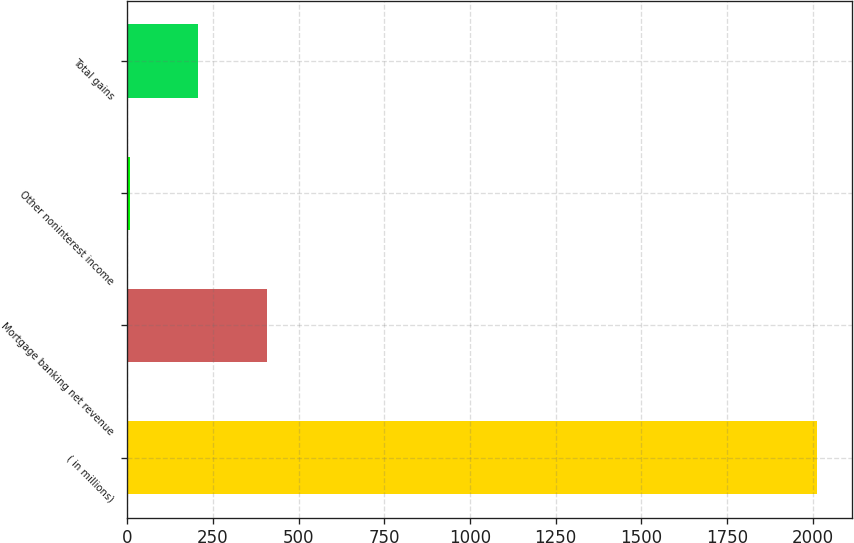Convert chart. <chart><loc_0><loc_0><loc_500><loc_500><bar_chart><fcel>( in millions)<fcel>Mortgage banking net revenue<fcel>Other noninterest income<fcel>Total gains<nl><fcel>2014<fcel>408.4<fcel>7<fcel>207.7<nl></chart> 